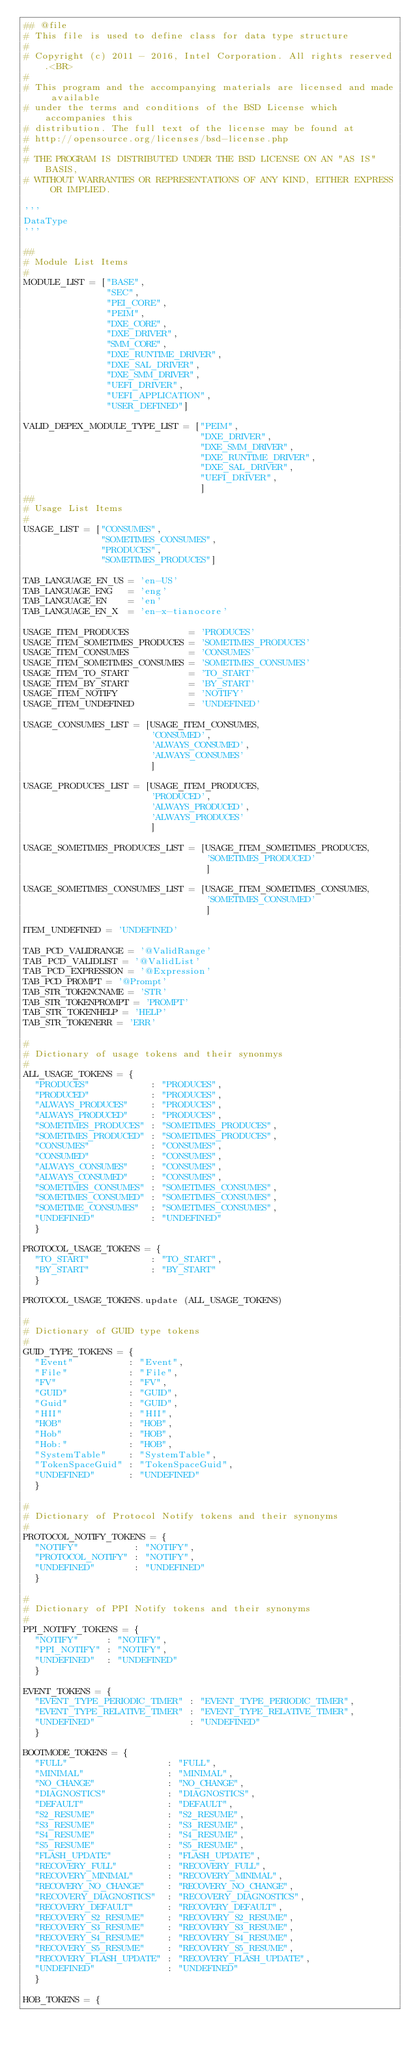Convert code to text. <code><loc_0><loc_0><loc_500><loc_500><_Python_>## @file
# This file is used to define class for data type structure
#
# Copyright (c) 2011 - 2016, Intel Corporation. All rights reserved.<BR>
#
# This program and the accompanying materials are licensed and made available 
# under the terms and conditions of the BSD License which accompanies this 
# distribution. The full text of the license may be found at 
# http://opensource.org/licenses/bsd-license.php
#
# THE PROGRAM IS DISTRIBUTED UNDER THE BSD LICENSE ON AN "AS IS" BASIS,
# WITHOUT WARRANTIES OR REPRESENTATIONS OF ANY KIND, EITHER EXPRESS OR IMPLIED.

'''
DataType
'''

##
# Module List Items
#
MODULE_LIST = ["BASE",
               "SEC",
               "PEI_CORE",
               "PEIM",
               "DXE_CORE",
               "DXE_DRIVER",
               "SMM_CORE",
               "DXE_RUNTIME_DRIVER",
               "DXE_SAL_DRIVER",
               "DXE_SMM_DRIVER",
               "UEFI_DRIVER",
               "UEFI_APPLICATION",
               "USER_DEFINED"]

VALID_DEPEX_MODULE_TYPE_LIST = ["PEIM",
                                "DXE_DRIVER",
                                "DXE_SMM_DRIVER",
                                "DXE_RUNTIME_DRIVER",
                                "DXE_SAL_DRIVER",
                                "UEFI_DRIVER",
                                ]
##
# Usage List Items
#
USAGE_LIST = ["CONSUMES",
              "SOMETIMES_CONSUMES",
              "PRODUCES",
              "SOMETIMES_PRODUCES"]

TAB_LANGUAGE_EN_US = 'en-US'
TAB_LANGUAGE_ENG   = 'eng'
TAB_LANGUAGE_EN    = 'en'
TAB_LANGUAGE_EN_X  = 'en-x-tianocore'

USAGE_ITEM_PRODUCES           = 'PRODUCES'
USAGE_ITEM_SOMETIMES_PRODUCES = 'SOMETIMES_PRODUCES'
USAGE_ITEM_CONSUMES           = 'CONSUMES'
USAGE_ITEM_SOMETIMES_CONSUMES = 'SOMETIMES_CONSUMES'
USAGE_ITEM_TO_START           = 'TO_START'
USAGE_ITEM_BY_START           = 'BY_START'
USAGE_ITEM_NOTIFY             = 'NOTIFY'
USAGE_ITEM_UNDEFINED          = 'UNDEFINED'

USAGE_CONSUMES_LIST = [USAGE_ITEM_CONSUMES,
                       'CONSUMED',
                       'ALWAYS_CONSUMED',
                       'ALWAYS_CONSUMES'                     
                       ]

USAGE_PRODUCES_LIST = [USAGE_ITEM_PRODUCES,
                       'PRODUCED',
                       'ALWAYS_PRODUCED',
                       'ALWAYS_PRODUCES'                     
                       ]

USAGE_SOMETIMES_PRODUCES_LIST = [USAGE_ITEM_SOMETIMES_PRODUCES,
                                 'SOMETIMES_PRODUCED'
                                 ]

USAGE_SOMETIMES_CONSUMES_LIST = [USAGE_ITEM_SOMETIMES_CONSUMES,
                                 'SOMETIMES_CONSUMED'
                                 ]

ITEM_UNDEFINED = 'UNDEFINED'

TAB_PCD_VALIDRANGE = '@ValidRange'
TAB_PCD_VALIDLIST = '@ValidList'
TAB_PCD_EXPRESSION = '@Expression'
TAB_PCD_PROMPT = '@Prompt'
TAB_STR_TOKENCNAME = 'STR'
TAB_STR_TOKENPROMPT = 'PROMPT'
TAB_STR_TOKENHELP = 'HELP'
TAB_STR_TOKENERR = 'ERR'

#
# Dictionary of usage tokens and their synonmys
#  
ALL_USAGE_TOKENS = {
  "PRODUCES"           : "PRODUCES",
  "PRODUCED"           : "PRODUCES",
  "ALWAYS_PRODUCES"    : "PRODUCES",
  "ALWAYS_PRODUCED"    : "PRODUCES",
  "SOMETIMES_PRODUCES" : "SOMETIMES_PRODUCES",
  "SOMETIMES_PRODUCED" : "SOMETIMES_PRODUCES",
  "CONSUMES"           : "CONSUMES",
  "CONSUMED"           : "CONSUMES",
  "ALWAYS_CONSUMES"    : "CONSUMES",
  "ALWAYS_CONSUMED"    : "CONSUMES",
  "SOMETIMES_CONSUMES" : "SOMETIMES_CONSUMES",
  "SOMETIMES_CONSUMED" : "SOMETIMES_CONSUMES",
  "SOMETIME_CONSUMES"  : "SOMETIMES_CONSUMES",
  "UNDEFINED"          : "UNDEFINED" 
  }

PROTOCOL_USAGE_TOKENS = {
  "TO_START"           : "TO_START",
  "BY_START"           : "BY_START"
  }
 
PROTOCOL_USAGE_TOKENS.update (ALL_USAGE_TOKENS)
  
#
# Dictionary of GUID type tokens
#  
GUID_TYPE_TOKENS = {  
  "Event"          : "Event",
  "File"           : "File",
  "FV"             : "FV",
  "GUID"           : "GUID",
  "Guid"           : "GUID",
  "HII"            : "HII",
  "HOB"            : "HOB",
  "Hob"            : "HOB",
  "Hob:"           : "HOB",
  "SystemTable"    : "SystemTable",
  "TokenSpaceGuid" : "TokenSpaceGuid",
  "UNDEFINED"      : "UNDEFINED" 
  }
  
#
# Dictionary of Protocol Notify tokens and their synonyms
#  
PROTOCOL_NOTIFY_TOKENS = {  
  "NOTIFY"          : "NOTIFY",
  "PROTOCOL_NOTIFY" : "NOTIFY",
  "UNDEFINED"       : "UNDEFINED" 
  }

#
# Dictionary of PPI Notify tokens and their synonyms
#  
PPI_NOTIFY_TOKENS = {  
  "NOTIFY"     : "NOTIFY",
  "PPI_NOTIFY" : "NOTIFY",
  "UNDEFINED"  : "UNDEFINED" 
  }

EVENT_TOKENS = {
  "EVENT_TYPE_PERIODIC_TIMER" : "EVENT_TYPE_PERIODIC_TIMER",
  "EVENT_TYPE_RELATIVE_TIMER" : "EVENT_TYPE_RELATIVE_TIMER",
  "UNDEFINED"                 : "UNDEFINED" 
  }

BOOTMODE_TOKENS = {
  "FULL"                  : "FULL",
  "MINIMAL"               : "MINIMAL",
  "NO_CHANGE"             : "NO_CHANGE",
  "DIAGNOSTICS"           : "DIAGNOSTICS",
  "DEFAULT"               : "DEFAULT",
  "S2_RESUME"             : "S2_RESUME",
  "S3_RESUME"             : "S3_RESUME",
  "S4_RESUME"             : "S4_RESUME",
  "S5_RESUME"             : "S5_RESUME",
  "FLASH_UPDATE"          : "FLASH_UPDATE",
  "RECOVERY_FULL"         : "RECOVERY_FULL",
  "RECOVERY_MINIMAL"      : "RECOVERY_MINIMAL",
  "RECOVERY_NO_CHANGE"    : "RECOVERY_NO_CHANGE",
  "RECOVERY_DIAGNOSTICS"  : "RECOVERY_DIAGNOSTICS",
  "RECOVERY_DEFAULT"      : "RECOVERY_DEFAULT",
  "RECOVERY_S2_RESUME"    : "RECOVERY_S2_RESUME",
  "RECOVERY_S3_RESUME"    : "RECOVERY_S3_RESUME",
  "RECOVERY_S4_RESUME"    : "RECOVERY_S4_RESUME",
  "RECOVERY_S5_RESUME"    : "RECOVERY_S5_RESUME",
  "RECOVERY_FLASH_UPDATE" : "RECOVERY_FLASH_UPDATE",
  "UNDEFINED"             : "UNDEFINED" 
  }

HOB_TOKENS = {  </code> 